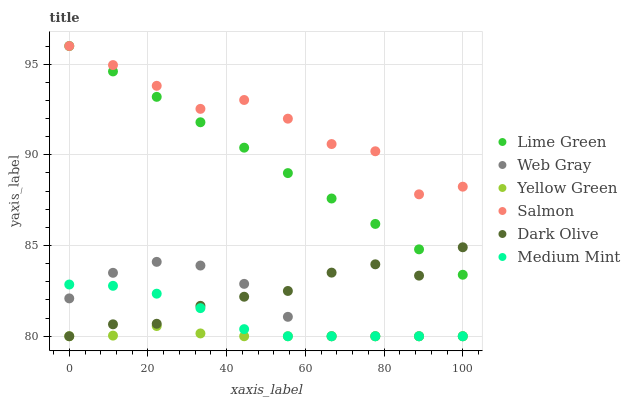Does Yellow Green have the minimum area under the curve?
Answer yes or no. Yes. Does Salmon have the maximum area under the curve?
Answer yes or no. Yes. Does Web Gray have the minimum area under the curve?
Answer yes or no. No. Does Web Gray have the maximum area under the curve?
Answer yes or no. No. Is Lime Green the smoothest?
Answer yes or no. Yes. Is Salmon the roughest?
Answer yes or no. Yes. Is Web Gray the smoothest?
Answer yes or no. No. Is Web Gray the roughest?
Answer yes or no. No. Does Medium Mint have the lowest value?
Answer yes or no. Yes. Does Dark Olive have the lowest value?
Answer yes or no. No. Does Lime Green have the highest value?
Answer yes or no. Yes. Does Web Gray have the highest value?
Answer yes or no. No. Is Yellow Green less than Lime Green?
Answer yes or no. Yes. Is Lime Green greater than Web Gray?
Answer yes or no. Yes. Does Web Gray intersect Yellow Green?
Answer yes or no. Yes. Is Web Gray less than Yellow Green?
Answer yes or no. No. Is Web Gray greater than Yellow Green?
Answer yes or no. No. Does Yellow Green intersect Lime Green?
Answer yes or no. No. 